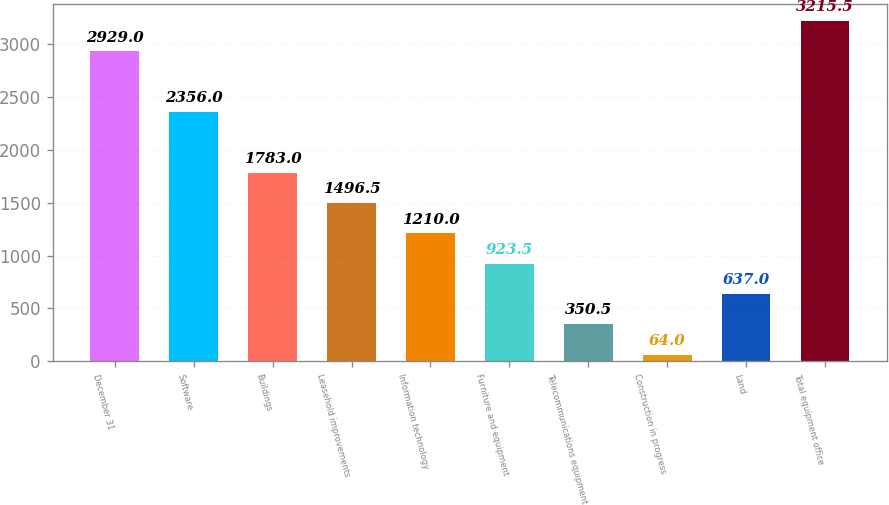Convert chart. <chart><loc_0><loc_0><loc_500><loc_500><bar_chart><fcel>December 31<fcel>Software<fcel>Buildings<fcel>Leasehold improvements<fcel>Information technology<fcel>Furniture and equipment<fcel>Telecommunications equipment<fcel>Construction in progress<fcel>Land<fcel>Total equipment office<nl><fcel>2929<fcel>2356<fcel>1783<fcel>1496.5<fcel>1210<fcel>923.5<fcel>350.5<fcel>64<fcel>637<fcel>3215.5<nl></chart> 